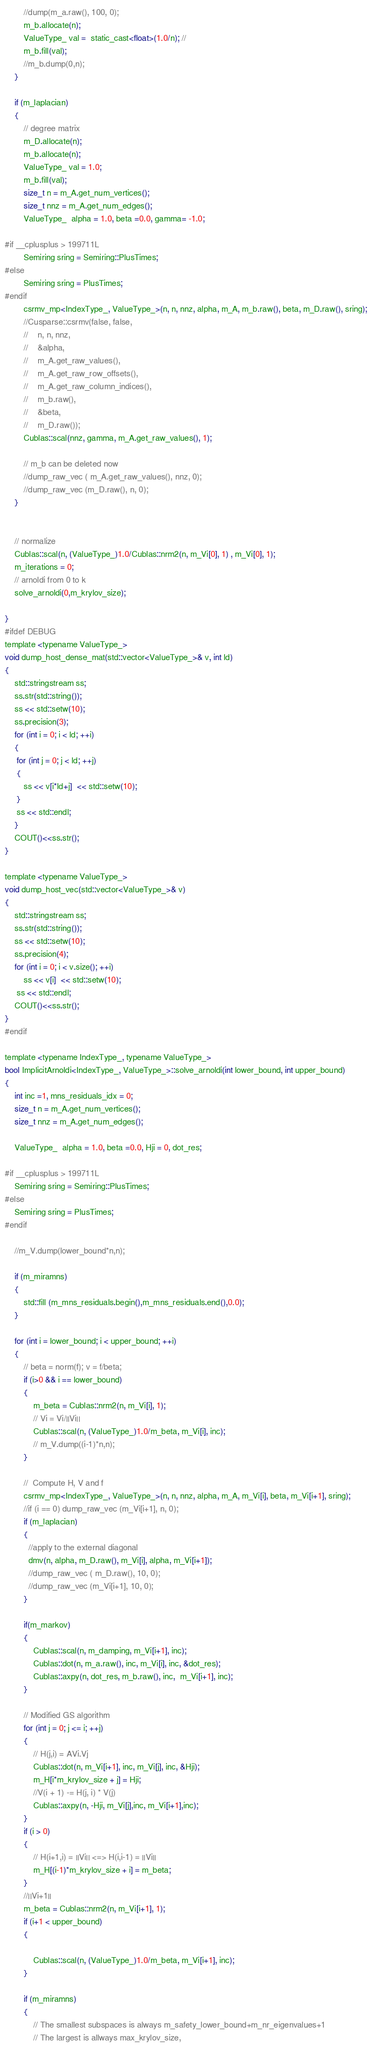Convert code to text. <code><loc_0><loc_0><loc_500><loc_500><_Cuda_>        //dump(m_a.raw(), 100, 0);
        m_b.allocate(n);
        ValueType_ val =  static_cast<float>(1.0/n); //
        m_b.fill(val);
        //m_b.dump(0,n);
    }

    if (m_laplacian)
    {
        // degree matrix
        m_D.allocate(n);
        m_b.allocate(n);
        ValueType_ val = 1.0;
        m_b.fill(val);
        size_t n = m_A.get_num_vertices();
        size_t nnz = m_A.get_num_edges();
        ValueType_  alpha = 1.0, beta =0.0, gamma= -1.0; 

#if __cplusplus > 199711L
        Semiring sring = Semiring::PlusTimes;   
#else 
        Semiring sring = PlusTimes;   
#endif
        csrmv_mp<IndexType_, ValueType_>(n, n, nnz, alpha, m_A, m_b.raw(), beta, m_D.raw(), sring);
        //Cusparse::csrmv(false, false, 
        //    n, n, nnz,
        //    &alpha,
        //    m_A.get_raw_values(),
        //    m_A.get_raw_row_offsets(),
        //    m_A.get_raw_column_indices(),
        //    m_b.raw(),
        //    &beta,
        //    m_D.raw());
        Cublas::scal(nnz, gamma, m_A.get_raw_values(), 1);
        
        // m_b can be deleted now
        //dump_raw_vec ( m_A.get_raw_values(), nnz, 0);
        //dump_raw_vec (m_D.raw(), n, 0);
    }


    // normalize
    Cublas::scal(n, (ValueType_)1.0/Cublas::nrm2(n, m_Vi[0], 1) , m_Vi[0], 1);
    m_iterations = 0;
    // arnoldi from 0 to k
    solve_arnoldi(0,m_krylov_size);
    
}
#ifdef DEBUG
template <typename ValueType_>
void dump_host_dense_mat(std::vector<ValueType_>& v, int ld)
{
    std::stringstream ss;
    ss.str(std::string());
    ss << std::setw(10);
    ss.precision(3);        
    for (int i = 0; i < ld; ++i)
    {
     for (int j = 0; j < ld; ++j)
     {
        ss << v[i*ld+j]  << std::setw(10);
     }  
     ss << std::endl;
    }
    COUT()<<ss.str();
}

template <typename ValueType_>
void dump_host_vec(std::vector<ValueType_>& v)
{
    std::stringstream ss;
    ss.str(std::string());
    ss << std::setw(10);
    ss.precision(4);        
    for (int i = 0; i < v.size(); ++i)
        ss << v[i]  << std::setw(10);
     ss << std::endl;
    COUT()<<ss.str();
}
#endif

template <typename IndexType_, typename ValueType_>
bool ImplicitArnoldi<IndexType_, ValueType_>::solve_arnoldi(int lower_bound, int upper_bound)
{
    int inc =1, mns_residuals_idx = 0;
    size_t n = m_A.get_num_vertices();
    size_t nnz = m_A.get_num_edges();

    ValueType_  alpha = 1.0, beta =0.0, Hji = 0, dot_res; 
   
#if __cplusplus > 199711L
    Semiring sring = Semiring::PlusTimes;   
#else
    Semiring sring = PlusTimes;   
#endif
    
    //m_V.dump(lower_bound*n,n);
    
    if (m_miramns) 
    {
        std::fill (m_mns_residuals.begin(),m_mns_residuals.end(),0.0);
    }

    for (int i = lower_bound; i < upper_bound; ++i)
    {
        // beta = norm(f); v = f/beta; 
        if (i>0 && i == lower_bound)
        {
            m_beta = Cublas::nrm2(n, m_Vi[i], 1);
            // Vi = Vi/||Vi||
            Cublas::scal(n, (ValueType_)1.0/m_beta, m_Vi[i], inc);
            // m_V.dump((i-1)*n,n);
        }

        //  Compute H, V and f
        csrmv_mp<IndexType_, ValueType_>(n, n, nnz, alpha, m_A, m_Vi[i], beta, m_Vi[i+1], sring);
        //if (i == 0) dump_raw_vec (m_Vi[i+1], n, 0);
        if (m_laplacian) 
        {
          //apply to the external diagonal
          dmv(n, alpha, m_D.raw(), m_Vi[i], alpha, m_Vi[i+1]);
          //dump_raw_vec ( m_D.raw(), 10, 0);
          //dump_raw_vec (m_Vi[i+1], 10, 0);
        }

        if(m_markov)
        {
            Cublas::scal(n, m_damping, m_Vi[i+1], inc);
            Cublas::dot(n, m_a.raw(), inc, m_Vi[i], inc, &dot_res); 
            Cublas::axpy(n, dot_res, m_b.raw(), inc,  m_Vi[i+1], inc); 
        }
        
        // Modified GS algorithm
        for (int j = 0; j <= i; ++j)
        {
            // H(j,i) = AVi.Vj
            Cublas::dot(n, m_Vi[i+1], inc, m_Vi[j], inc, &Hji);
            m_H[i*m_krylov_size + j] = Hji;
            //V(i + 1) -= H(j, i) * V(j) 
            Cublas::axpy(n, -Hji, m_Vi[j],inc, m_Vi[i+1],inc);
        }
        if (i > 0)
        {
            // H(i+1,i) = ||Vi|| <=> H(i,i-1) = ||Vi||
            m_H[(i-1)*m_krylov_size + i] = m_beta;
        }
        //||Vi+1||
        m_beta = Cublas::nrm2(n, m_Vi[i+1], 1);
        if (i+1 < upper_bound) 
        {
            
            Cublas::scal(n, (ValueType_)1.0/m_beta, m_Vi[i+1], inc);
        }

        if (m_miramns) 
        {
            // The smallest subspaces is always m_safety_lower_bound+m_nr_eigenvalues+1
            // The largest is allways max_krylov_size, </code> 